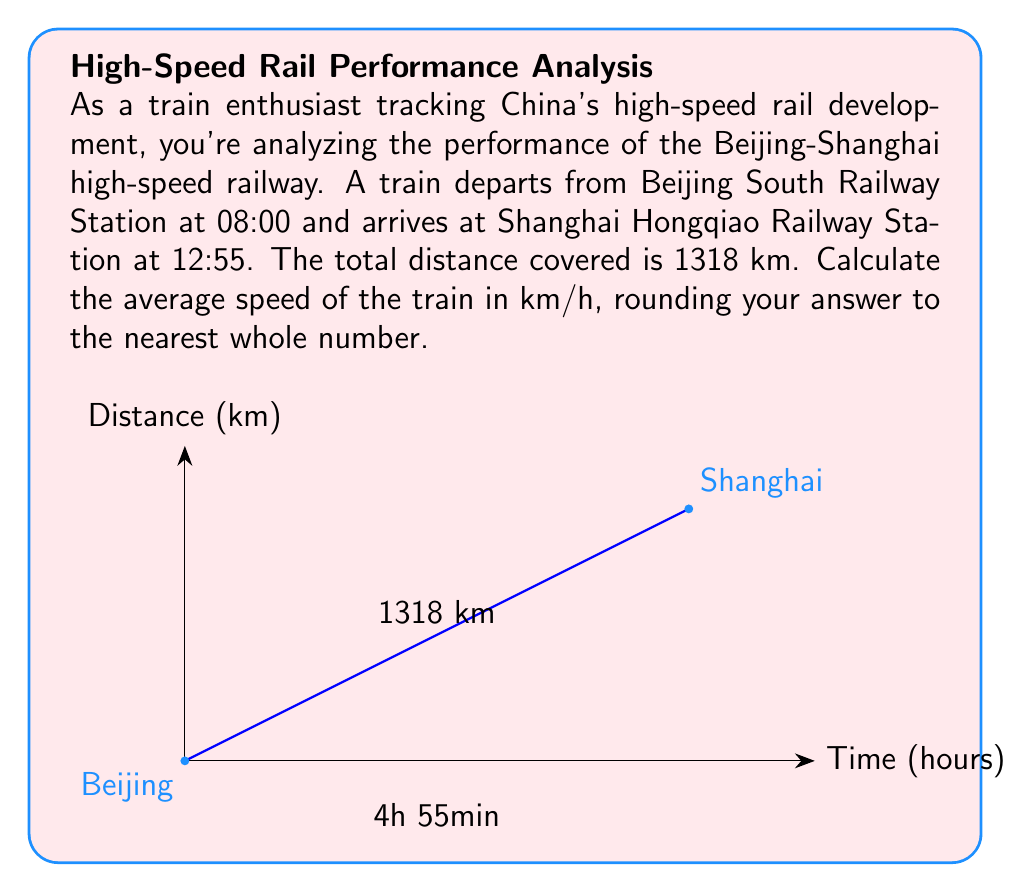Solve this math problem. To calculate the average speed, we need to use the formula:

$$\text{Average Speed} = \frac{\text{Total Distance}}{\text{Total Time}}$$

Let's break down the problem step-by-step:

1) First, we need to calculate the total time:
   * Departure time: 08:00
   * Arrival time: 12:55
   * Time difference: 4 hours and 55 minutes
   * Convert to hours: $4 + \frac{55}{60} = 4.9167$ hours

2) We have the following information:
   * Distance: 1318 km
   * Time: 4.9167 hours

3) Now, let's apply the formula:

   $$\text{Average Speed} = \frac{1318 \text{ km}}{4.9167 \text{ hours}}$$

4) Perform the division:

   $$\text{Average Speed} = 268.0677 \text{ km/h}$$

5) Rounding to the nearest whole number:

   $$\text{Average Speed} \approx 268 \text{ km/h}$$
Answer: 268 km/h 